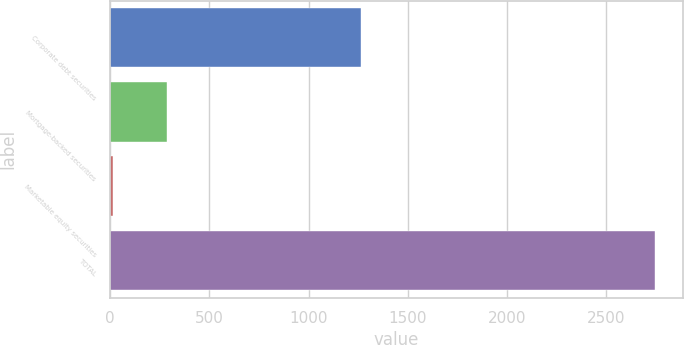Convert chart to OTSL. <chart><loc_0><loc_0><loc_500><loc_500><bar_chart><fcel>Corporate debt securities<fcel>Mortgage-backed securities<fcel>Marketable equity securities<fcel>TOTAL<nl><fcel>1263<fcel>287.5<fcel>14<fcel>2749<nl></chart> 